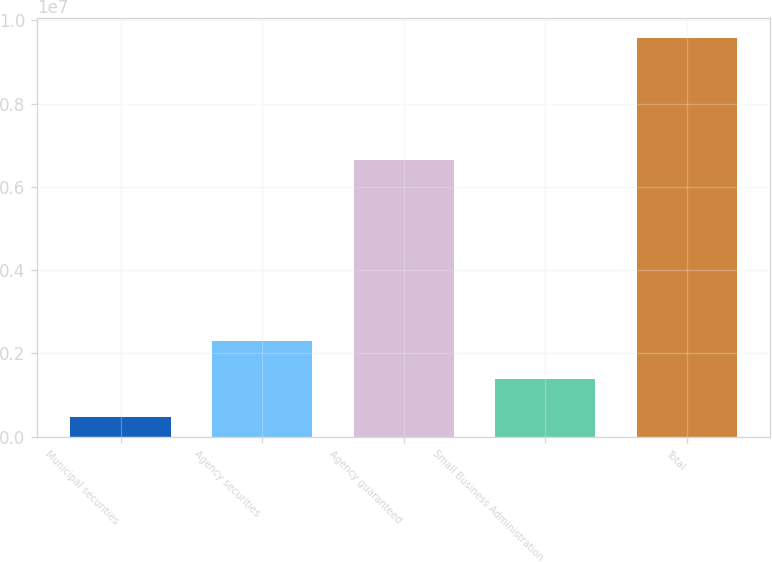<chart> <loc_0><loc_0><loc_500><loc_500><bar_chart><fcel>Municipal securities<fcel>Agency securities<fcel>Agency guaranteed<fcel>Small Business Administration<fcel>Total<nl><fcel>467056<fcel>2.29072e+06<fcel>6.64925e+06<fcel>1.37889e+06<fcel>9.58536e+06<nl></chart> 